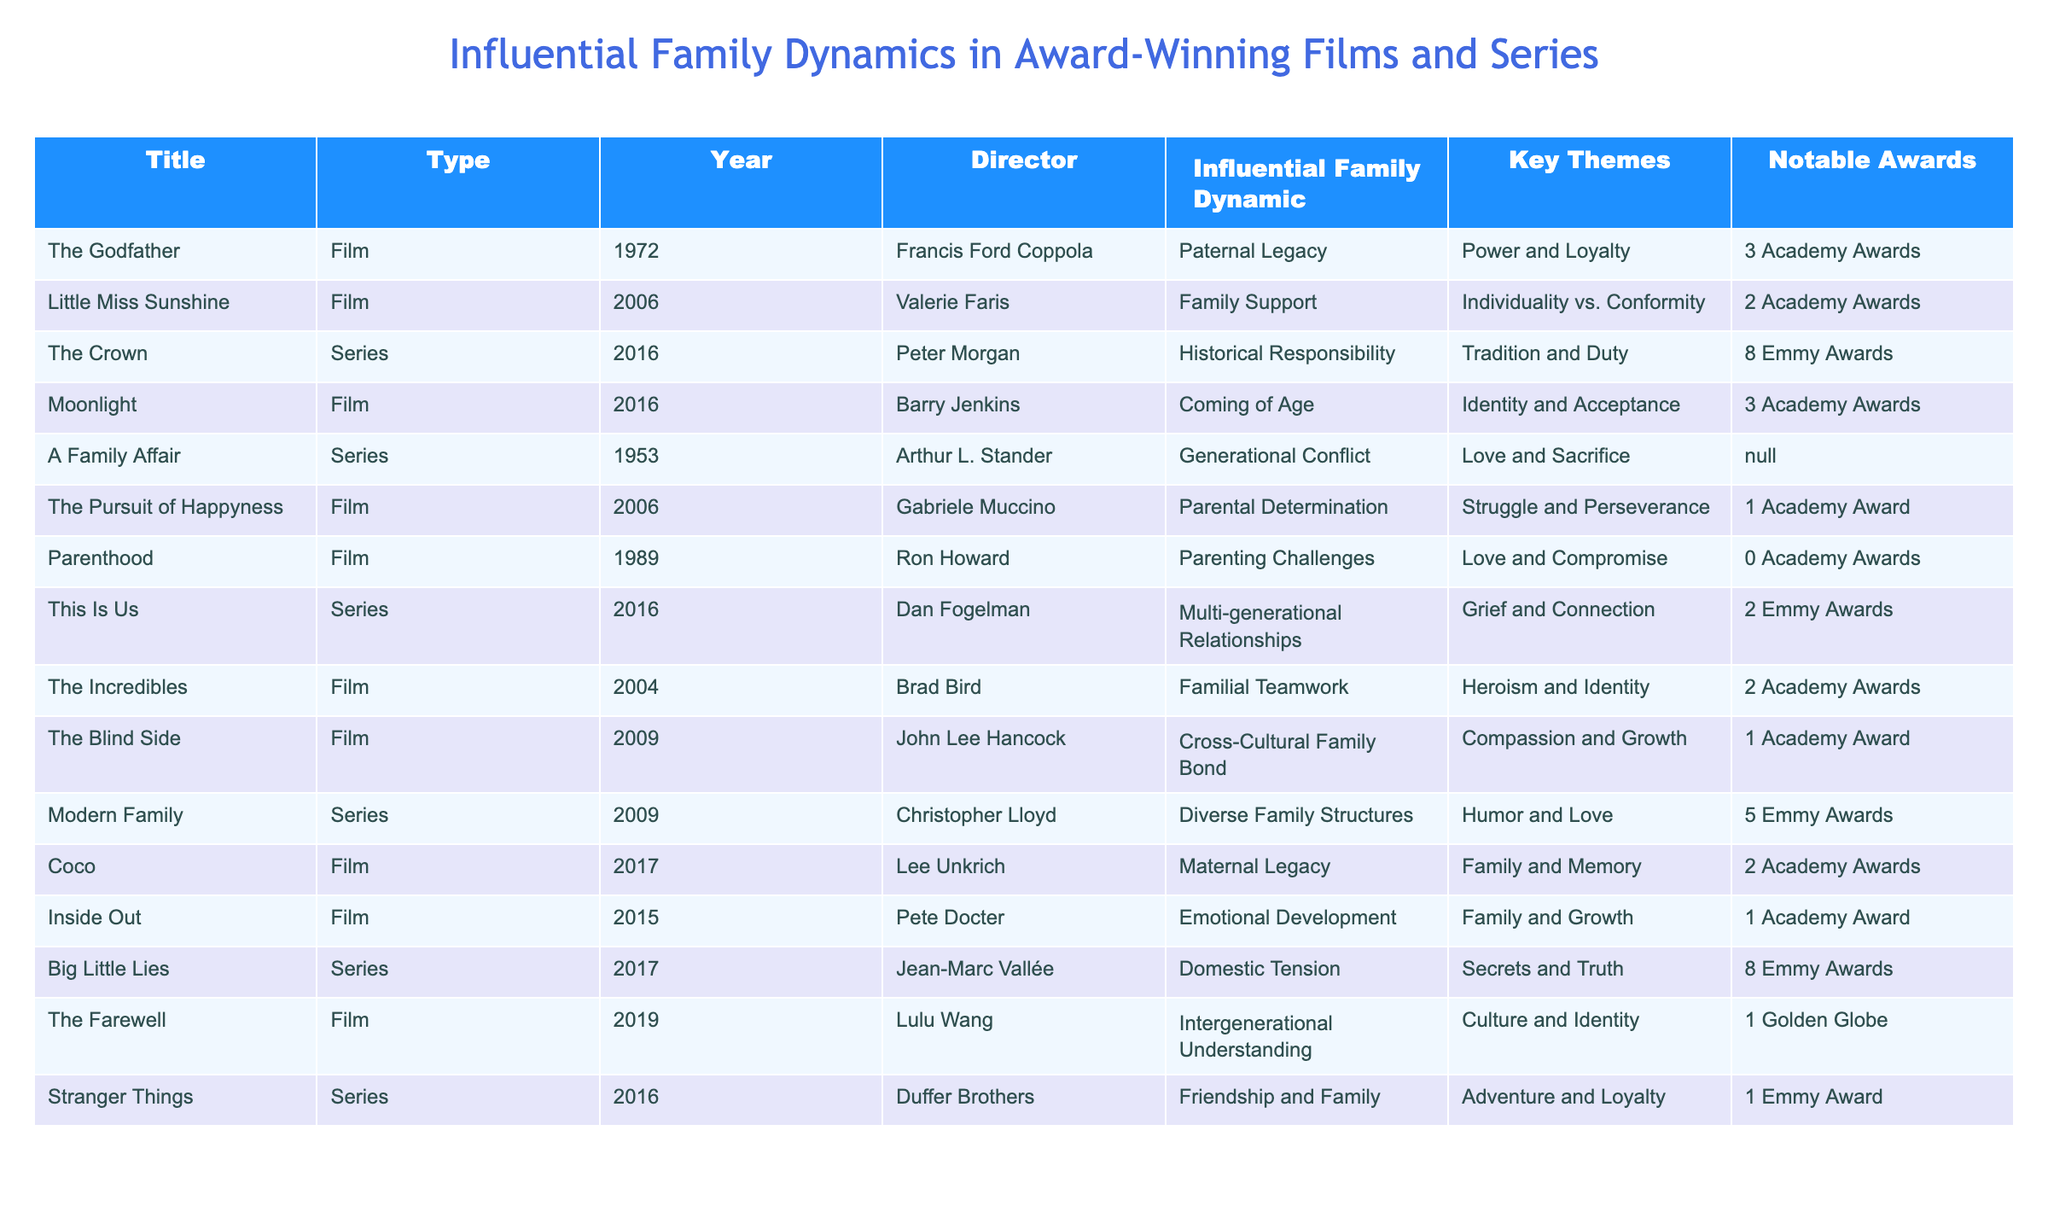What influential family dynamic is featured in "Little Miss Sunshine"? The table indicates that the influential family dynamic in "Little Miss Sunshine" is "Family Support." This can be found in the row for that specific title in the "Influential Family Dynamic" column.
Answer: Family Support Which film received the most Academy Awards? By reviewing the "Notable Awards" column, "The Godfather" is listed with 3 Academy Awards, which is more than any other film in the table.
Answer: The Godfather True or False: "The Crown" won more Emmy Awards than "Big Little Lies". The table shows that "The Crown" won 8 Emmy Awards while "Big Little Lies" won 8 as well. Therefore, they are equal, making this statement false.
Answer: False What is the key theme of "The Pursuit of Happyness"? According to the table, the key theme associated with "The Pursuit of Happyness" is "Struggle and Perseverance." This is listed in the corresponding row under the "Key Themes" column.
Answer: Struggle and Perseverance How many films in the table focus on "Parental Determination" and "Maternal Legacy" combined? There is one film focusing on "Parental Determination" (The Pursuit of Happyness) and one film focusing on "Maternal Legacy" (Coco). Adding these gives a total of 1+1=2 films.
Answer: 2 Which series has the highest number of Emmy Awards? The number of Emmy Awards listed in "The Crown" and "Big Little Lies" is 8 each, more than any other series in the table. So, both series can be considered the top.
Answer: The Crown and Big Little Lies What influential family dynamic is shared between "This Is Us" and "The Blind Side"? The table indicates that "This Is Us" features "Multi-generational Relationships" while "The Blind Side" features "Cross-Cultural Family Bond." These dynamics are different; therefore, there is no shared influential family dynamic.
Answer: None In which year was "Coco" released, and how many Academy Awards did it win? "Coco" is listed under the "Year" column as 2017 and has 2 Academy Awards mentioned in the "Notable Awards" column. Thus, both pieces of information can be retrieved directly from the table.
Answer: 2017, 2 Academy Awards 